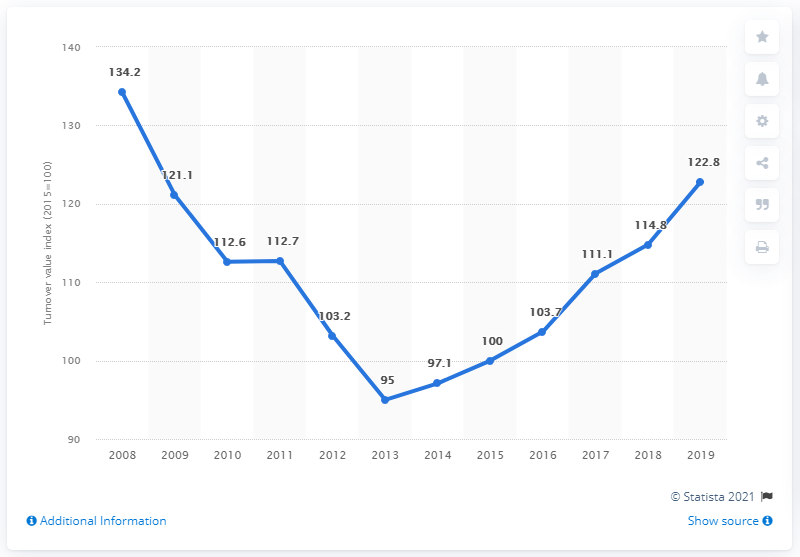List a handful of essential elements in this visual. In 2018 and 2019, the turnover value of DIY retail stores exceeded the level achieved in 2010. The turnover value of DIY retail stores increased again in what year? In 2013. 